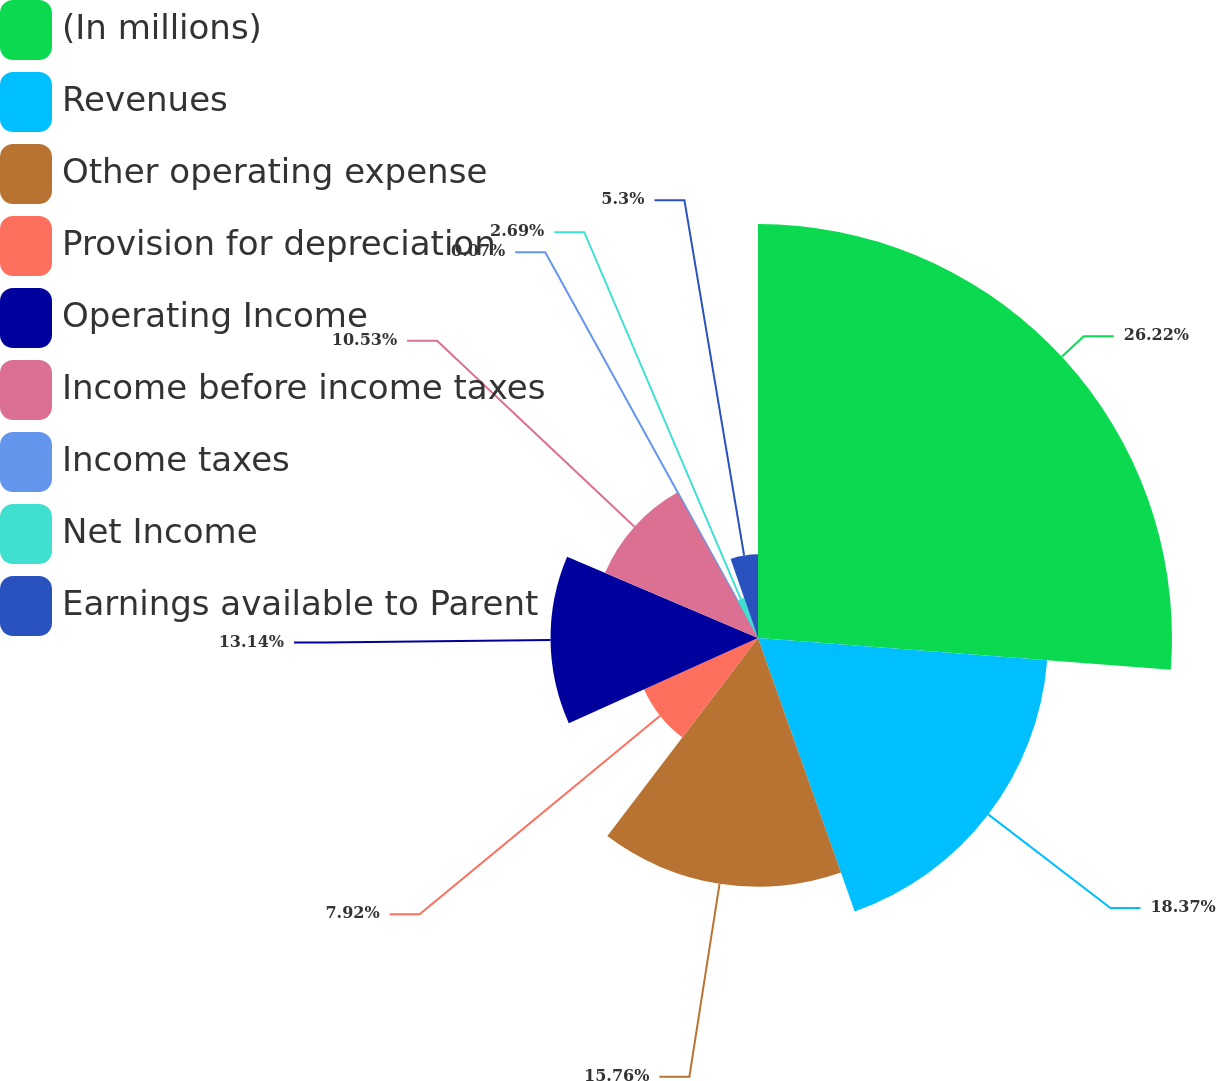Convert chart to OTSL. <chart><loc_0><loc_0><loc_500><loc_500><pie_chart><fcel>(In millions)<fcel>Revenues<fcel>Other operating expense<fcel>Provision for depreciation<fcel>Operating Income<fcel>Income before income taxes<fcel>Income taxes<fcel>Net Income<fcel>Earnings available to Parent<nl><fcel>26.22%<fcel>18.37%<fcel>15.76%<fcel>7.92%<fcel>13.14%<fcel>10.53%<fcel>0.07%<fcel>2.69%<fcel>5.3%<nl></chart> 